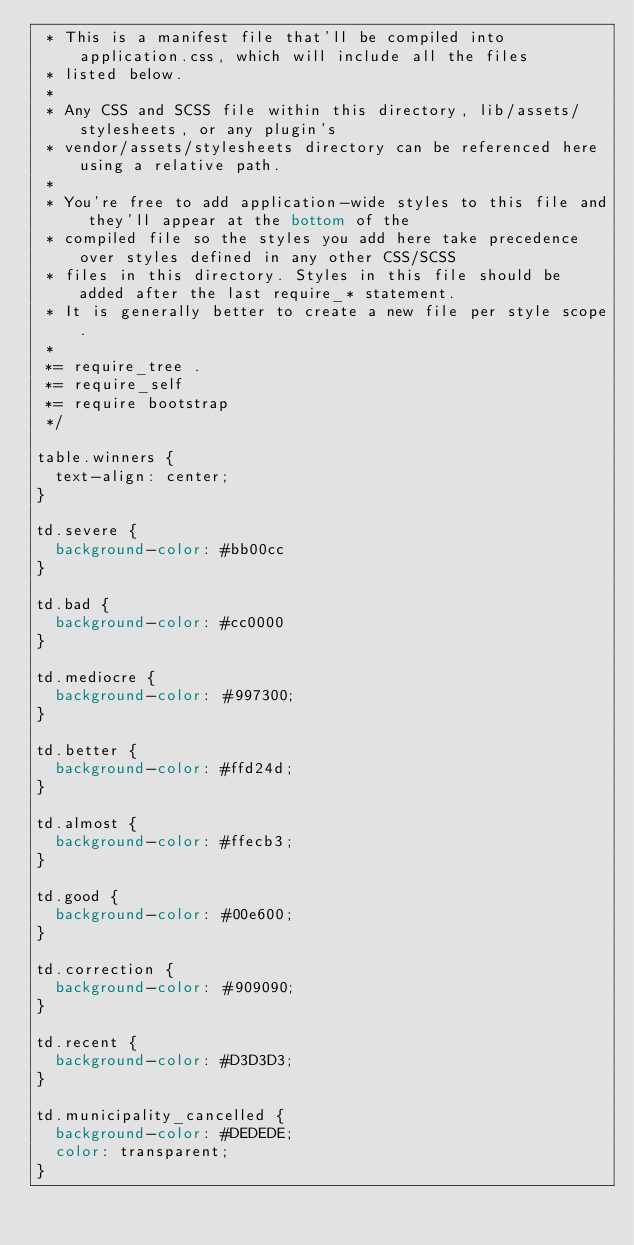Convert code to text. <code><loc_0><loc_0><loc_500><loc_500><_CSS_> * This is a manifest file that'll be compiled into application.css, which will include all the files
 * listed below.
 *
 * Any CSS and SCSS file within this directory, lib/assets/stylesheets, or any plugin's
 * vendor/assets/stylesheets directory can be referenced here using a relative path.
 *
 * You're free to add application-wide styles to this file and they'll appear at the bottom of the
 * compiled file so the styles you add here take precedence over styles defined in any other CSS/SCSS
 * files in this directory. Styles in this file should be added after the last require_* statement.
 * It is generally better to create a new file per style scope.
 *
 *= require_tree .
 *= require_self
 *= require bootstrap
 */

table.winners {
  text-align: center;
}

td.severe {
  background-color: #bb00cc
}

td.bad {
  background-color: #cc0000
}

td.mediocre {
  background-color: #997300;
}

td.better {
  background-color: #ffd24d;
}

td.almost {
  background-color: #ffecb3;
}

td.good {
  background-color: #00e600;
}

td.correction {
  background-color: #909090;
}

td.recent {
  background-color: #D3D3D3;
}

td.municipality_cancelled {
  background-color: #DEDEDE;
  color: transparent;
}
</code> 